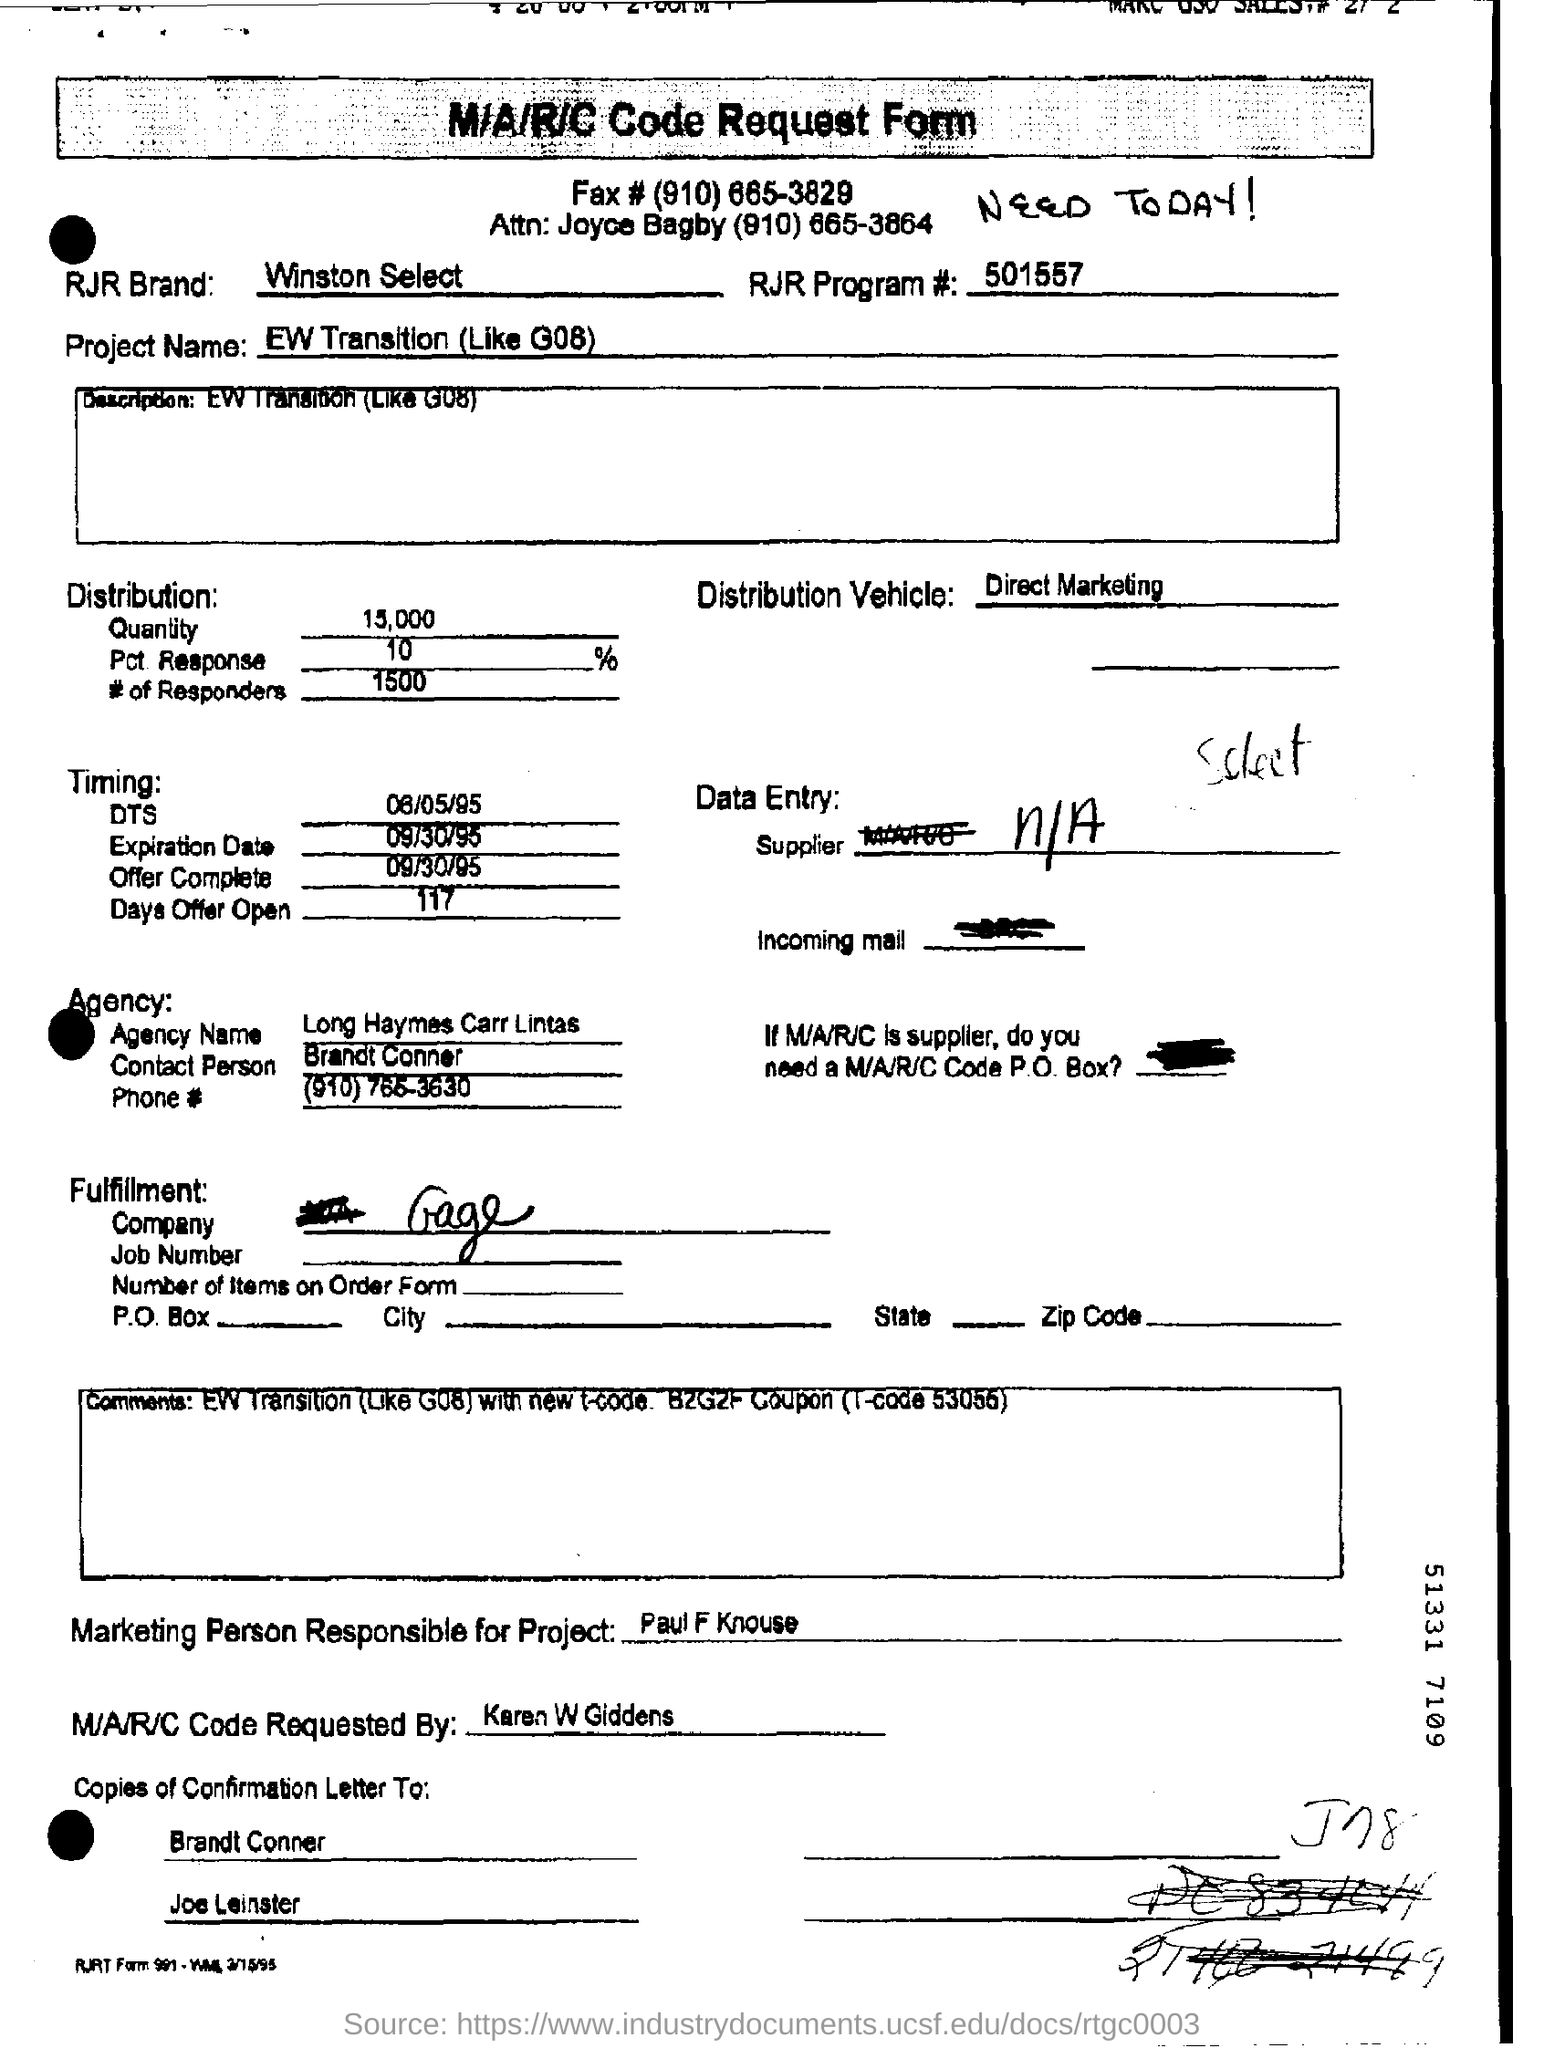Give some essential details in this illustration. Who requested the MAC code? Karen W. Giddens did. This offer is open for 117 days. The expiration date mentioned in the request form is September 30, 1995. The project name mentioned in the request form is "ew transition (like G08).". The marketing person responsible for the project is Paul F. Knouse. 